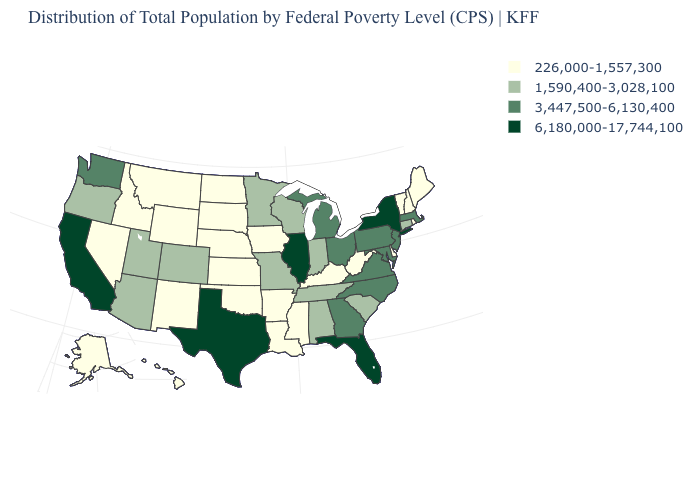What is the lowest value in the USA?
Answer briefly. 226,000-1,557,300. Among the states that border New Jersey , does Delaware have the lowest value?
Give a very brief answer. Yes. Which states have the lowest value in the USA?
Keep it brief. Alaska, Arkansas, Delaware, Hawaii, Idaho, Iowa, Kansas, Kentucky, Louisiana, Maine, Mississippi, Montana, Nebraska, Nevada, New Hampshire, New Mexico, North Dakota, Oklahoma, Rhode Island, South Dakota, Vermont, West Virginia, Wyoming. What is the value of Michigan?
Keep it brief. 3,447,500-6,130,400. What is the value of Oklahoma?
Answer briefly. 226,000-1,557,300. Among the states that border Rhode Island , which have the lowest value?
Give a very brief answer. Connecticut. Name the states that have a value in the range 226,000-1,557,300?
Write a very short answer. Alaska, Arkansas, Delaware, Hawaii, Idaho, Iowa, Kansas, Kentucky, Louisiana, Maine, Mississippi, Montana, Nebraska, Nevada, New Hampshire, New Mexico, North Dakota, Oklahoma, Rhode Island, South Dakota, Vermont, West Virginia, Wyoming. Name the states that have a value in the range 226,000-1,557,300?
Answer briefly. Alaska, Arkansas, Delaware, Hawaii, Idaho, Iowa, Kansas, Kentucky, Louisiana, Maine, Mississippi, Montana, Nebraska, Nevada, New Hampshire, New Mexico, North Dakota, Oklahoma, Rhode Island, South Dakota, Vermont, West Virginia, Wyoming. Name the states that have a value in the range 1,590,400-3,028,100?
Quick response, please. Alabama, Arizona, Colorado, Connecticut, Indiana, Minnesota, Missouri, Oregon, South Carolina, Tennessee, Utah, Wisconsin. Does Iowa have the lowest value in the USA?
Quick response, please. Yes. How many symbols are there in the legend?
Short answer required. 4. Which states have the lowest value in the South?
Short answer required. Arkansas, Delaware, Kentucky, Louisiana, Mississippi, Oklahoma, West Virginia. What is the value of Missouri?
Answer briefly. 1,590,400-3,028,100. Name the states that have a value in the range 6,180,000-17,744,100?
Short answer required. California, Florida, Illinois, New York, Texas. Name the states that have a value in the range 6,180,000-17,744,100?
Write a very short answer. California, Florida, Illinois, New York, Texas. 